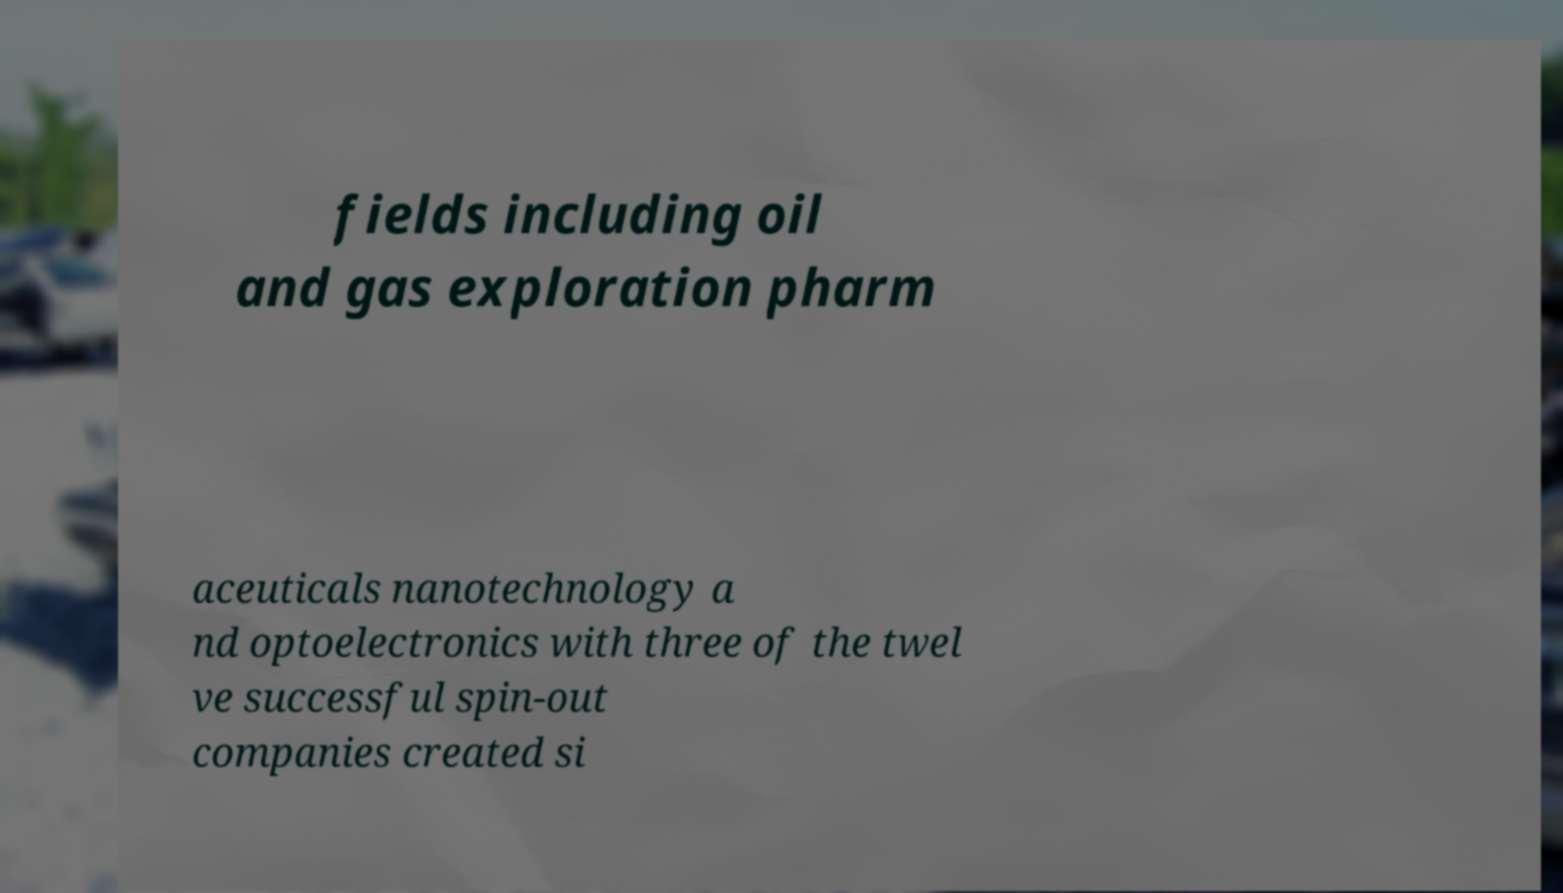For documentation purposes, I need the text within this image transcribed. Could you provide that? fields including oil and gas exploration pharm aceuticals nanotechnology a nd optoelectronics with three of the twel ve successful spin-out companies created si 